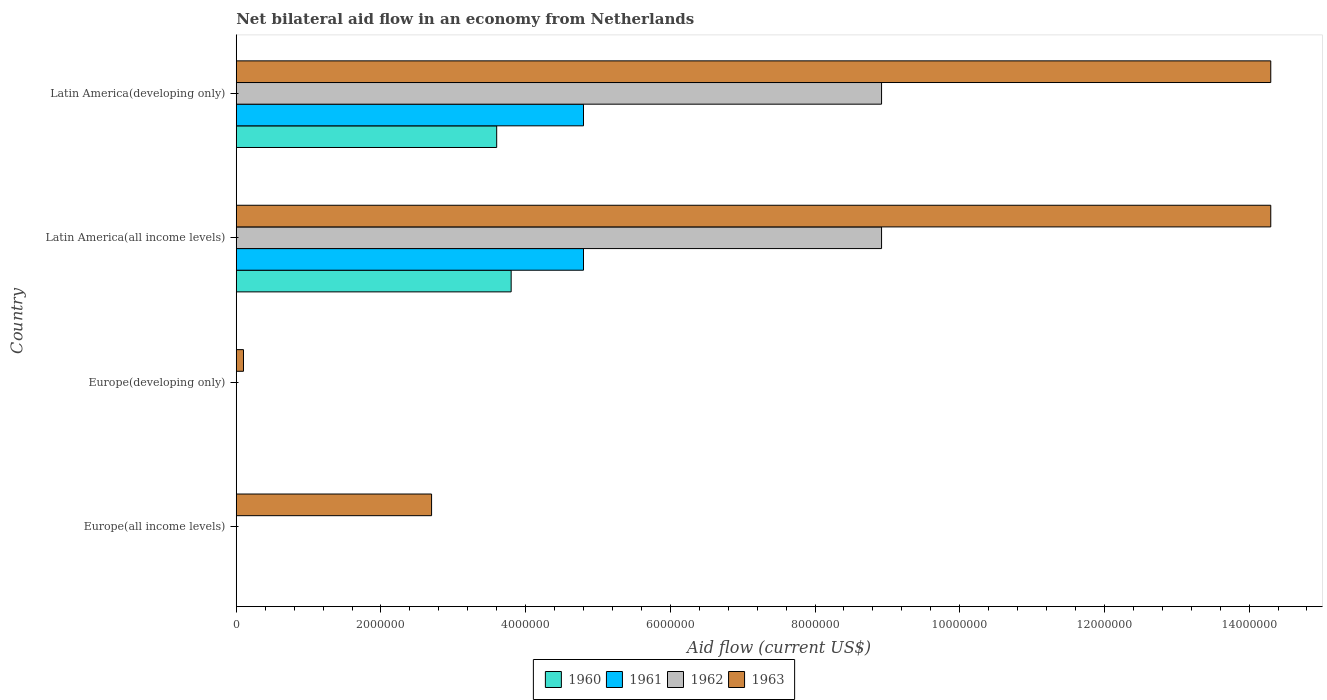How many bars are there on the 1st tick from the top?
Give a very brief answer. 4. What is the label of the 1st group of bars from the top?
Keep it short and to the point. Latin America(developing only). What is the net bilateral aid flow in 1962 in Europe(all income levels)?
Offer a very short reply. 0. Across all countries, what is the maximum net bilateral aid flow in 1963?
Provide a succinct answer. 1.43e+07. In which country was the net bilateral aid flow in 1963 maximum?
Ensure brevity in your answer.  Latin America(all income levels). What is the total net bilateral aid flow in 1963 in the graph?
Your response must be concise. 3.14e+07. What is the difference between the net bilateral aid flow in 1963 in Europe(developing only) and that in Latin America(all income levels)?
Your response must be concise. -1.42e+07. What is the difference between the net bilateral aid flow in 1962 in Europe(developing only) and the net bilateral aid flow in 1960 in Europe(all income levels)?
Keep it short and to the point. 0. What is the average net bilateral aid flow in 1961 per country?
Give a very brief answer. 2.40e+06. What is the difference between the net bilateral aid flow in 1961 and net bilateral aid flow in 1960 in Latin America(developing only)?
Provide a short and direct response. 1.20e+06. In how many countries, is the net bilateral aid flow in 1960 greater than 10800000 US$?
Your answer should be very brief. 0. What is the ratio of the net bilateral aid flow in 1960 in Latin America(all income levels) to that in Latin America(developing only)?
Make the answer very short. 1.06. Is the net bilateral aid flow in 1960 in Latin America(all income levels) less than that in Latin America(developing only)?
Your response must be concise. No. What is the difference between the highest and the lowest net bilateral aid flow in 1963?
Offer a terse response. 1.42e+07. In how many countries, is the net bilateral aid flow in 1960 greater than the average net bilateral aid flow in 1960 taken over all countries?
Keep it short and to the point. 2. Is it the case that in every country, the sum of the net bilateral aid flow in 1962 and net bilateral aid flow in 1960 is greater than the sum of net bilateral aid flow in 1961 and net bilateral aid flow in 1963?
Make the answer very short. No. How many bars are there?
Offer a very short reply. 10. How many countries are there in the graph?
Keep it short and to the point. 4. Does the graph contain grids?
Ensure brevity in your answer.  No. How many legend labels are there?
Your answer should be compact. 4. How are the legend labels stacked?
Keep it short and to the point. Horizontal. What is the title of the graph?
Provide a succinct answer. Net bilateral aid flow in an economy from Netherlands. Does "1961" appear as one of the legend labels in the graph?
Keep it short and to the point. Yes. What is the label or title of the X-axis?
Offer a terse response. Aid flow (current US$). What is the Aid flow (current US$) of 1960 in Europe(all income levels)?
Give a very brief answer. 0. What is the Aid flow (current US$) of 1961 in Europe(all income levels)?
Your response must be concise. 0. What is the Aid flow (current US$) of 1962 in Europe(all income levels)?
Give a very brief answer. 0. What is the Aid flow (current US$) of 1963 in Europe(all income levels)?
Ensure brevity in your answer.  2.70e+06. What is the Aid flow (current US$) in 1961 in Europe(developing only)?
Your answer should be very brief. 0. What is the Aid flow (current US$) in 1960 in Latin America(all income levels)?
Your answer should be compact. 3.80e+06. What is the Aid flow (current US$) in 1961 in Latin America(all income levels)?
Your response must be concise. 4.80e+06. What is the Aid flow (current US$) in 1962 in Latin America(all income levels)?
Keep it short and to the point. 8.92e+06. What is the Aid flow (current US$) of 1963 in Latin America(all income levels)?
Provide a succinct answer. 1.43e+07. What is the Aid flow (current US$) of 1960 in Latin America(developing only)?
Make the answer very short. 3.60e+06. What is the Aid flow (current US$) in 1961 in Latin America(developing only)?
Keep it short and to the point. 4.80e+06. What is the Aid flow (current US$) in 1962 in Latin America(developing only)?
Provide a short and direct response. 8.92e+06. What is the Aid flow (current US$) in 1963 in Latin America(developing only)?
Ensure brevity in your answer.  1.43e+07. Across all countries, what is the maximum Aid flow (current US$) in 1960?
Offer a terse response. 3.80e+06. Across all countries, what is the maximum Aid flow (current US$) of 1961?
Your response must be concise. 4.80e+06. Across all countries, what is the maximum Aid flow (current US$) in 1962?
Your answer should be compact. 8.92e+06. Across all countries, what is the maximum Aid flow (current US$) of 1963?
Provide a short and direct response. 1.43e+07. Across all countries, what is the minimum Aid flow (current US$) in 1963?
Provide a succinct answer. 1.00e+05. What is the total Aid flow (current US$) in 1960 in the graph?
Give a very brief answer. 7.40e+06. What is the total Aid flow (current US$) in 1961 in the graph?
Your answer should be very brief. 9.60e+06. What is the total Aid flow (current US$) of 1962 in the graph?
Your response must be concise. 1.78e+07. What is the total Aid flow (current US$) of 1963 in the graph?
Your response must be concise. 3.14e+07. What is the difference between the Aid flow (current US$) in 1963 in Europe(all income levels) and that in Europe(developing only)?
Your answer should be very brief. 2.60e+06. What is the difference between the Aid flow (current US$) of 1963 in Europe(all income levels) and that in Latin America(all income levels)?
Provide a short and direct response. -1.16e+07. What is the difference between the Aid flow (current US$) in 1963 in Europe(all income levels) and that in Latin America(developing only)?
Give a very brief answer. -1.16e+07. What is the difference between the Aid flow (current US$) of 1963 in Europe(developing only) and that in Latin America(all income levels)?
Keep it short and to the point. -1.42e+07. What is the difference between the Aid flow (current US$) of 1963 in Europe(developing only) and that in Latin America(developing only)?
Offer a terse response. -1.42e+07. What is the difference between the Aid flow (current US$) in 1960 in Latin America(all income levels) and that in Latin America(developing only)?
Your response must be concise. 2.00e+05. What is the difference between the Aid flow (current US$) of 1961 in Latin America(all income levels) and that in Latin America(developing only)?
Offer a very short reply. 0. What is the difference between the Aid flow (current US$) in 1963 in Latin America(all income levels) and that in Latin America(developing only)?
Ensure brevity in your answer.  0. What is the difference between the Aid flow (current US$) in 1960 in Latin America(all income levels) and the Aid flow (current US$) in 1961 in Latin America(developing only)?
Keep it short and to the point. -1.00e+06. What is the difference between the Aid flow (current US$) in 1960 in Latin America(all income levels) and the Aid flow (current US$) in 1962 in Latin America(developing only)?
Give a very brief answer. -5.12e+06. What is the difference between the Aid flow (current US$) of 1960 in Latin America(all income levels) and the Aid flow (current US$) of 1963 in Latin America(developing only)?
Keep it short and to the point. -1.05e+07. What is the difference between the Aid flow (current US$) in 1961 in Latin America(all income levels) and the Aid flow (current US$) in 1962 in Latin America(developing only)?
Keep it short and to the point. -4.12e+06. What is the difference between the Aid flow (current US$) in 1961 in Latin America(all income levels) and the Aid flow (current US$) in 1963 in Latin America(developing only)?
Provide a succinct answer. -9.50e+06. What is the difference between the Aid flow (current US$) in 1962 in Latin America(all income levels) and the Aid flow (current US$) in 1963 in Latin America(developing only)?
Give a very brief answer. -5.38e+06. What is the average Aid flow (current US$) of 1960 per country?
Your answer should be very brief. 1.85e+06. What is the average Aid flow (current US$) in 1961 per country?
Provide a short and direct response. 2.40e+06. What is the average Aid flow (current US$) of 1962 per country?
Your answer should be very brief. 4.46e+06. What is the average Aid flow (current US$) of 1963 per country?
Give a very brief answer. 7.85e+06. What is the difference between the Aid flow (current US$) in 1960 and Aid flow (current US$) in 1961 in Latin America(all income levels)?
Offer a terse response. -1.00e+06. What is the difference between the Aid flow (current US$) in 1960 and Aid flow (current US$) in 1962 in Latin America(all income levels)?
Keep it short and to the point. -5.12e+06. What is the difference between the Aid flow (current US$) of 1960 and Aid flow (current US$) of 1963 in Latin America(all income levels)?
Provide a succinct answer. -1.05e+07. What is the difference between the Aid flow (current US$) in 1961 and Aid flow (current US$) in 1962 in Latin America(all income levels)?
Give a very brief answer. -4.12e+06. What is the difference between the Aid flow (current US$) of 1961 and Aid flow (current US$) of 1963 in Latin America(all income levels)?
Your response must be concise. -9.50e+06. What is the difference between the Aid flow (current US$) of 1962 and Aid flow (current US$) of 1963 in Latin America(all income levels)?
Your answer should be very brief. -5.38e+06. What is the difference between the Aid flow (current US$) of 1960 and Aid flow (current US$) of 1961 in Latin America(developing only)?
Your answer should be very brief. -1.20e+06. What is the difference between the Aid flow (current US$) in 1960 and Aid flow (current US$) in 1962 in Latin America(developing only)?
Provide a succinct answer. -5.32e+06. What is the difference between the Aid flow (current US$) of 1960 and Aid flow (current US$) of 1963 in Latin America(developing only)?
Your response must be concise. -1.07e+07. What is the difference between the Aid flow (current US$) in 1961 and Aid flow (current US$) in 1962 in Latin America(developing only)?
Give a very brief answer. -4.12e+06. What is the difference between the Aid flow (current US$) of 1961 and Aid flow (current US$) of 1963 in Latin America(developing only)?
Keep it short and to the point. -9.50e+06. What is the difference between the Aid flow (current US$) in 1962 and Aid flow (current US$) in 1963 in Latin America(developing only)?
Your response must be concise. -5.38e+06. What is the ratio of the Aid flow (current US$) of 1963 in Europe(all income levels) to that in Europe(developing only)?
Your answer should be very brief. 27. What is the ratio of the Aid flow (current US$) of 1963 in Europe(all income levels) to that in Latin America(all income levels)?
Offer a very short reply. 0.19. What is the ratio of the Aid flow (current US$) of 1963 in Europe(all income levels) to that in Latin America(developing only)?
Offer a terse response. 0.19. What is the ratio of the Aid flow (current US$) of 1963 in Europe(developing only) to that in Latin America(all income levels)?
Offer a very short reply. 0.01. What is the ratio of the Aid flow (current US$) in 1963 in Europe(developing only) to that in Latin America(developing only)?
Offer a very short reply. 0.01. What is the ratio of the Aid flow (current US$) of 1960 in Latin America(all income levels) to that in Latin America(developing only)?
Ensure brevity in your answer.  1.06. What is the difference between the highest and the second highest Aid flow (current US$) of 1963?
Ensure brevity in your answer.  0. What is the difference between the highest and the lowest Aid flow (current US$) in 1960?
Ensure brevity in your answer.  3.80e+06. What is the difference between the highest and the lowest Aid flow (current US$) in 1961?
Provide a succinct answer. 4.80e+06. What is the difference between the highest and the lowest Aid flow (current US$) of 1962?
Offer a terse response. 8.92e+06. What is the difference between the highest and the lowest Aid flow (current US$) of 1963?
Make the answer very short. 1.42e+07. 